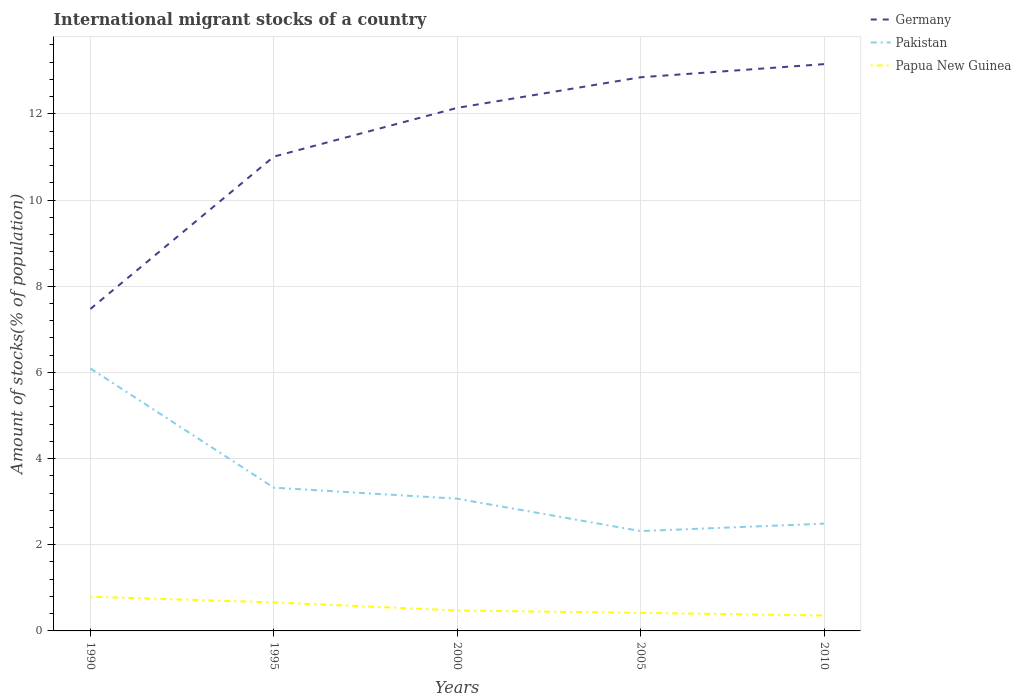How many different coloured lines are there?
Ensure brevity in your answer.  3. Is the number of lines equal to the number of legend labels?
Give a very brief answer. Yes. Across all years, what is the maximum amount of stocks in in Papua New Guinea?
Provide a short and direct response. 0.36. In which year was the amount of stocks in in Pakistan maximum?
Your response must be concise. 2005. What is the total amount of stocks in in Pakistan in the graph?
Your answer should be very brief. 0.75. What is the difference between the highest and the second highest amount of stocks in in Germany?
Your answer should be very brief. 5.68. What is the difference between the highest and the lowest amount of stocks in in Pakistan?
Offer a terse response. 1. Is the amount of stocks in in Papua New Guinea strictly greater than the amount of stocks in in Pakistan over the years?
Your response must be concise. Yes. How many years are there in the graph?
Make the answer very short. 5. Does the graph contain grids?
Keep it short and to the point. Yes. Where does the legend appear in the graph?
Provide a succinct answer. Top right. What is the title of the graph?
Offer a terse response. International migrant stocks of a country. What is the label or title of the Y-axis?
Your answer should be very brief. Amount of stocks(% of population). What is the Amount of stocks(% of population) in Germany in 1990?
Keep it short and to the point. 7.47. What is the Amount of stocks(% of population) of Pakistan in 1990?
Your response must be concise. 6.09. What is the Amount of stocks(% of population) in Papua New Guinea in 1990?
Your answer should be very brief. 0.79. What is the Amount of stocks(% of population) of Germany in 1995?
Provide a short and direct response. 11.01. What is the Amount of stocks(% of population) of Pakistan in 1995?
Offer a terse response. 3.33. What is the Amount of stocks(% of population) of Papua New Guinea in 1995?
Your answer should be compact. 0.66. What is the Amount of stocks(% of population) in Germany in 2000?
Your answer should be compact. 12.14. What is the Amount of stocks(% of population) of Pakistan in 2000?
Your response must be concise. 3.07. What is the Amount of stocks(% of population) of Papua New Guinea in 2000?
Ensure brevity in your answer.  0.47. What is the Amount of stocks(% of population) of Germany in 2005?
Provide a short and direct response. 12.85. What is the Amount of stocks(% of population) in Pakistan in 2005?
Give a very brief answer. 2.32. What is the Amount of stocks(% of population) in Papua New Guinea in 2005?
Keep it short and to the point. 0.42. What is the Amount of stocks(% of population) in Germany in 2010?
Offer a terse response. 13.16. What is the Amount of stocks(% of population) in Pakistan in 2010?
Provide a short and direct response. 2.49. What is the Amount of stocks(% of population) of Papua New Guinea in 2010?
Keep it short and to the point. 0.36. Across all years, what is the maximum Amount of stocks(% of population) of Germany?
Provide a short and direct response. 13.16. Across all years, what is the maximum Amount of stocks(% of population) of Pakistan?
Offer a very short reply. 6.09. Across all years, what is the maximum Amount of stocks(% of population) in Papua New Guinea?
Your answer should be compact. 0.79. Across all years, what is the minimum Amount of stocks(% of population) of Germany?
Ensure brevity in your answer.  7.47. Across all years, what is the minimum Amount of stocks(% of population) of Pakistan?
Offer a terse response. 2.32. Across all years, what is the minimum Amount of stocks(% of population) in Papua New Guinea?
Make the answer very short. 0.36. What is the total Amount of stocks(% of population) of Germany in the graph?
Offer a terse response. 56.63. What is the total Amount of stocks(% of population) in Pakistan in the graph?
Provide a short and direct response. 17.29. What is the total Amount of stocks(% of population) in Papua New Guinea in the graph?
Ensure brevity in your answer.  2.71. What is the difference between the Amount of stocks(% of population) in Germany in 1990 and that in 1995?
Keep it short and to the point. -3.54. What is the difference between the Amount of stocks(% of population) of Pakistan in 1990 and that in 1995?
Ensure brevity in your answer.  2.77. What is the difference between the Amount of stocks(% of population) of Papua New Guinea in 1990 and that in 1995?
Your response must be concise. 0.13. What is the difference between the Amount of stocks(% of population) of Germany in 1990 and that in 2000?
Your answer should be compact. -4.67. What is the difference between the Amount of stocks(% of population) in Pakistan in 1990 and that in 2000?
Make the answer very short. 3.02. What is the difference between the Amount of stocks(% of population) of Papua New Guinea in 1990 and that in 2000?
Keep it short and to the point. 0.32. What is the difference between the Amount of stocks(% of population) of Germany in 1990 and that in 2005?
Ensure brevity in your answer.  -5.38. What is the difference between the Amount of stocks(% of population) of Pakistan in 1990 and that in 2005?
Provide a short and direct response. 3.77. What is the difference between the Amount of stocks(% of population) in Papua New Guinea in 1990 and that in 2005?
Your answer should be compact. 0.38. What is the difference between the Amount of stocks(% of population) in Germany in 1990 and that in 2010?
Your answer should be compact. -5.68. What is the difference between the Amount of stocks(% of population) of Pakistan in 1990 and that in 2010?
Give a very brief answer. 3.6. What is the difference between the Amount of stocks(% of population) of Papua New Guinea in 1990 and that in 2010?
Offer a terse response. 0.44. What is the difference between the Amount of stocks(% of population) of Germany in 1995 and that in 2000?
Offer a terse response. -1.13. What is the difference between the Amount of stocks(% of population) in Pakistan in 1995 and that in 2000?
Give a very brief answer. 0.26. What is the difference between the Amount of stocks(% of population) of Papua New Guinea in 1995 and that in 2000?
Make the answer very short. 0.19. What is the difference between the Amount of stocks(% of population) of Germany in 1995 and that in 2005?
Offer a very short reply. -1.84. What is the difference between the Amount of stocks(% of population) in Pakistan in 1995 and that in 2005?
Your response must be concise. 1.01. What is the difference between the Amount of stocks(% of population) of Papua New Guinea in 1995 and that in 2005?
Make the answer very short. 0.24. What is the difference between the Amount of stocks(% of population) in Germany in 1995 and that in 2010?
Offer a very short reply. -2.15. What is the difference between the Amount of stocks(% of population) in Pakistan in 1995 and that in 2010?
Provide a succinct answer. 0.84. What is the difference between the Amount of stocks(% of population) in Papua New Guinea in 1995 and that in 2010?
Provide a succinct answer. 0.3. What is the difference between the Amount of stocks(% of population) of Germany in 2000 and that in 2005?
Your response must be concise. -0.71. What is the difference between the Amount of stocks(% of population) of Pakistan in 2000 and that in 2005?
Make the answer very short. 0.75. What is the difference between the Amount of stocks(% of population) of Papua New Guinea in 2000 and that in 2005?
Offer a very short reply. 0.06. What is the difference between the Amount of stocks(% of population) of Germany in 2000 and that in 2010?
Ensure brevity in your answer.  -1.02. What is the difference between the Amount of stocks(% of population) of Pakistan in 2000 and that in 2010?
Offer a very short reply. 0.58. What is the difference between the Amount of stocks(% of population) in Papua New Guinea in 2000 and that in 2010?
Make the answer very short. 0.12. What is the difference between the Amount of stocks(% of population) of Germany in 2005 and that in 2010?
Offer a very short reply. -0.3. What is the difference between the Amount of stocks(% of population) of Pakistan in 2005 and that in 2010?
Your answer should be very brief. -0.17. What is the difference between the Amount of stocks(% of population) of Papua New Guinea in 2005 and that in 2010?
Make the answer very short. 0.06. What is the difference between the Amount of stocks(% of population) of Germany in 1990 and the Amount of stocks(% of population) of Pakistan in 1995?
Your answer should be compact. 4.15. What is the difference between the Amount of stocks(% of population) of Germany in 1990 and the Amount of stocks(% of population) of Papua New Guinea in 1995?
Your response must be concise. 6.81. What is the difference between the Amount of stocks(% of population) in Pakistan in 1990 and the Amount of stocks(% of population) in Papua New Guinea in 1995?
Your response must be concise. 5.43. What is the difference between the Amount of stocks(% of population) in Germany in 1990 and the Amount of stocks(% of population) in Pakistan in 2000?
Provide a short and direct response. 4.4. What is the difference between the Amount of stocks(% of population) in Germany in 1990 and the Amount of stocks(% of population) in Papua New Guinea in 2000?
Offer a terse response. 7. What is the difference between the Amount of stocks(% of population) of Pakistan in 1990 and the Amount of stocks(% of population) of Papua New Guinea in 2000?
Keep it short and to the point. 5.62. What is the difference between the Amount of stocks(% of population) in Germany in 1990 and the Amount of stocks(% of population) in Pakistan in 2005?
Your answer should be very brief. 5.16. What is the difference between the Amount of stocks(% of population) in Germany in 1990 and the Amount of stocks(% of population) in Papua New Guinea in 2005?
Offer a very short reply. 7.05. What is the difference between the Amount of stocks(% of population) of Pakistan in 1990 and the Amount of stocks(% of population) of Papua New Guinea in 2005?
Your answer should be very brief. 5.67. What is the difference between the Amount of stocks(% of population) in Germany in 1990 and the Amount of stocks(% of population) in Pakistan in 2010?
Make the answer very short. 4.98. What is the difference between the Amount of stocks(% of population) in Germany in 1990 and the Amount of stocks(% of population) in Papua New Guinea in 2010?
Keep it short and to the point. 7.11. What is the difference between the Amount of stocks(% of population) of Pakistan in 1990 and the Amount of stocks(% of population) of Papua New Guinea in 2010?
Your answer should be compact. 5.73. What is the difference between the Amount of stocks(% of population) of Germany in 1995 and the Amount of stocks(% of population) of Pakistan in 2000?
Your answer should be very brief. 7.94. What is the difference between the Amount of stocks(% of population) in Germany in 1995 and the Amount of stocks(% of population) in Papua New Guinea in 2000?
Your answer should be compact. 10.53. What is the difference between the Amount of stocks(% of population) in Pakistan in 1995 and the Amount of stocks(% of population) in Papua New Guinea in 2000?
Your answer should be very brief. 2.85. What is the difference between the Amount of stocks(% of population) in Germany in 1995 and the Amount of stocks(% of population) in Pakistan in 2005?
Ensure brevity in your answer.  8.69. What is the difference between the Amount of stocks(% of population) of Germany in 1995 and the Amount of stocks(% of population) of Papua New Guinea in 2005?
Give a very brief answer. 10.59. What is the difference between the Amount of stocks(% of population) in Pakistan in 1995 and the Amount of stocks(% of population) in Papua New Guinea in 2005?
Keep it short and to the point. 2.91. What is the difference between the Amount of stocks(% of population) of Germany in 1995 and the Amount of stocks(% of population) of Pakistan in 2010?
Offer a terse response. 8.52. What is the difference between the Amount of stocks(% of population) in Germany in 1995 and the Amount of stocks(% of population) in Papua New Guinea in 2010?
Provide a succinct answer. 10.65. What is the difference between the Amount of stocks(% of population) in Pakistan in 1995 and the Amount of stocks(% of population) in Papua New Guinea in 2010?
Provide a succinct answer. 2.97. What is the difference between the Amount of stocks(% of population) of Germany in 2000 and the Amount of stocks(% of population) of Pakistan in 2005?
Make the answer very short. 9.82. What is the difference between the Amount of stocks(% of population) of Germany in 2000 and the Amount of stocks(% of population) of Papua New Guinea in 2005?
Ensure brevity in your answer.  11.72. What is the difference between the Amount of stocks(% of population) of Pakistan in 2000 and the Amount of stocks(% of population) of Papua New Guinea in 2005?
Ensure brevity in your answer.  2.65. What is the difference between the Amount of stocks(% of population) of Germany in 2000 and the Amount of stocks(% of population) of Pakistan in 2010?
Provide a succinct answer. 9.65. What is the difference between the Amount of stocks(% of population) of Germany in 2000 and the Amount of stocks(% of population) of Papua New Guinea in 2010?
Offer a terse response. 11.78. What is the difference between the Amount of stocks(% of population) in Pakistan in 2000 and the Amount of stocks(% of population) in Papua New Guinea in 2010?
Offer a terse response. 2.71. What is the difference between the Amount of stocks(% of population) in Germany in 2005 and the Amount of stocks(% of population) in Pakistan in 2010?
Offer a very short reply. 10.36. What is the difference between the Amount of stocks(% of population) in Germany in 2005 and the Amount of stocks(% of population) in Papua New Guinea in 2010?
Make the answer very short. 12.49. What is the difference between the Amount of stocks(% of population) in Pakistan in 2005 and the Amount of stocks(% of population) in Papua New Guinea in 2010?
Your answer should be very brief. 1.96. What is the average Amount of stocks(% of population) of Germany per year?
Provide a succinct answer. 11.33. What is the average Amount of stocks(% of population) of Pakistan per year?
Keep it short and to the point. 3.46. What is the average Amount of stocks(% of population) in Papua New Guinea per year?
Your response must be concise. 0.54. In the year 1990, what is the difference between the Amount of stocks(% of population) in Germany and Amount of stocks(% of population) in Pakistan?
Make the answer very short. 1.38. In the year 1990, what is the difference between the Amount of stocks(% of population) of Germany and Amount of stocks(% of population) of Papua New Guinea?
Your response must be concise. 6.68. In the year 1990, what is the difference between the Amount of stocks(% of population) of Pakistan and Amount of stocks(% of population) of Papua New Guinea?
Offer a terse response. 5.3. In the year 1995, what is the difference between the Amount of stocks(% of population) of Germany and Amount of stocks(% of population) of Pakistan?
Offer a terse response. 7.68. In the year 1995, what is the difference between the Amount of stocks(% of population) of Germany and Amount of stocks(% of population) of Papua New Guinea?
Your answer should be compact. 10.35. In the year 1995, what is the difference between the Amount of stocks(% of population) of Pakistan and Amount of stocks(% of population) of Papua New Guinea?
Your answer should be compact. 2.66. In the year 2000, what is the difference between the Amount of stocks(% of population) in Germany and Amount of stocks(% of population) in Pakistan?
Ensure brevity in your answer.  9.07. In the year 2000, what is the difference between the Amount of stocks(% of population) of Germany and Amount of stocks(% of population) of Papua New Guinea?
Offer a terse response. 11.67. In the year 2000, what is the difference between the Amount of stocks(% of population) in Pakistan and Amount of stocks(% of population) in Papua New Guinea?
Keep it short and to the point. 2.59. In the year 2005, what is the difference between the Amount of stocks(% of population) in Germany and Amount of stocks(% of population) in Pakistan?
Offer a terse response. 10.53. In the year 2005, what is the difference between the Amount of stocks(% of population) in Germany and Amount of stocks(% of population) in Papua New Guinea?
Keep it short and to the point. 12.43. In the year 2005, what is the difference between the Amount of stocks(% of population) in Pakistan and Amount of stocks(% of population) in Papua New Guinea?
Ensure brevity in your answer.  1.9. In the year 2010, what is the difference between the Amount of stocks(% of population) of Germany and Amount of stocks(% of population) of Pakistan?
Your response must be concise. 10.67. In the year 2010, what is the difference between the Amount of stocks(% of population) in Germany and Amount of stocks(% of population) in Papua New Guinea?
Provide a succinct answer. 12.8. In the year 2010, what is the difference between the Amount of stocks(% of population) of Pakistan and Amount of stocks(% of population) of Papua New Guinea?
Your answer should be compact. 2.13. What is the ratio of the Amount of stocks(% of population) of Germany in 1990 to that in 1995?
Offer a terse response. 0.68. What is the ratio of the Amount of stocks(% of population) in Pakistan in 1990 to that in 1995?
Ensure brevity in your answer.  1.83. What is the ratio of the Amount of stocks(% of population) in Papua New Guinea in 1990 to that in 1995?
Offer a terse response. 1.2. What is the ratio of the Amount of stocks(% of population) of Germany in 1990 to that in 2000?
Provide a short and direct response. 0.62. What is the ratio of the Amount of stocks(% of population) of Pakistan in 1990 to that in 2000?
Your answer should be very brief. 1.99. What is the ratio of the Amount of stocks(% of population) in Papua New Guinea in 1990 to that in 2000?
Ensure brevity in your answer.  1.67. What is the ratio of the Amount of stocks(% of population) of Germany in 1990 to that in 2005?
Your answer should be compact. 0.58. What is the ratio of the Amount of stocks(% of population) in Pakistan in 1990 to that in 2005?
Offer a very short reply. 2.63. What is the ratio of the Amount of stocks(% of population) in Papua New Guinea in 1990 to that in 2005?
Your response must be concise. 1.9. What is the ratio of the Amount of stocks(% of population) of Germany in 1990 to that in 2010?
Give a very brief answer. 0.57. What is the ratio of the Amount of stocks(% of population) in Pakistan in 1990 to that in 2010?
Give a very brief answer. 2.45. What is the ratio of the Amount of stocks(% of population) of Papua New Guinea in 1990 to that in 2010?
Give a very brief answer. 2.22. What is the ratio of the Amount of stocks(% of population) in Germany in 1995 to that in 2000?
Keep it short and to the point. 0.91. What is the ratio of the Amount of stocks(% of population) of Pakistan in 1995 to that in 2000?
Ensure brevity in your answer.  1.08. What is the ratio of the Amount of stocks(% of population) in Papua New Guinea in 1995 to that in 2000?
Offer a very short reply. 1.4. What is the ratio of the Amount of stocks(% of population) of Germany in 1995 to that in 2005?
Your answer should be compact. 0.86. What is the ratio of the Amount of stocks(% of population) in Pakistan in 1995 to that in 2005?
Ensure brevity in your answer.  1.43. What is the ratio of the Amount of stocks(% of population) in Papua New Guinea in 1995 to that in 2005?
Offer a terse response. 1.58. What is the ratio of the Amount of stocks(% of population) of Germany in 1995 to that in 2010?
Your answer should be very brief. 0.84. What is the ratio of the Amount of stocks(% of population) of Pakistan in 1995 to that in 2010?
Offer a very short reply. 1.34. What is the ratio of the Amount of stocks(% of population) of Papua New Guinea in 1995 to that in 2010?
Provide a succinct answer. 1.85. What is the ratio of the Amount of stocks(% of population) of Germany in 2000 to that in 2005?
Make the answer very short. 0.94. What is the ratio of the Amount of stocks(% of population) of Pakistan in 2000 to that in 2005?
Keep it short and to the point. 1.32. What is the ratio of the Amount of stocks(% of population) of Papua New Guinea in 2000 to that in 2005?
Provide a succinct answer. 1.13. What is the ratio of the Amount of stocks(% of population) of Germany in 2000 to that in 2010?
Your answer should be very brief. 0.92. What is the ratio of the Amount of stocks(% of population) in Pakistan in 2000 to that in 2010?
Provide a short and direct response. 1.23. What is the ratio of the Amount of stocks(% of population) in Papua New Guinea in 2000 to that in 2010?
Offer a very short reply. 1.32. What is the ratio of the Amount of stocks(% of population) in Germany in 2005 to that in 2010?
Offer a very short reply. 0.98. What is the ratio of the Amount of stocks(% of population) of Pakistan in 2005 to that in 2010?
Your answer should be compact. 0.93. What is the ratio of the Amount of stocks(% of population) in Papua New Guinea in 2005 to that in 2010?
Your response must be concise. 1.17. What is the difference between the highest and the second highest Amount of stocks(% of population) in Germany?
Your answer should be compact. 0.3. What is the difference between the highest and the second highest Amount of stocks(% of population) of Pakistan?
Provide a short and direct response. 2.77. What is the difference between the highest and the second highest Amount of stocks(% of population) in Papua New Guinea?
Offer a very short reply. 0.13. What is the difference between the highest and the lowest Amount of stocks(% of population) of Germany?
Ensure brevity in your answer.  5.68. What is the difference between the highest and the lowest Amount of stocks(% of population) of Pakistan?
Make the answer very short. 3.77. What is the difference between the highest and the lowest Amount of stocks(% of population) in Papua New Guinea?
Keep it short and to the point. 0.44. 